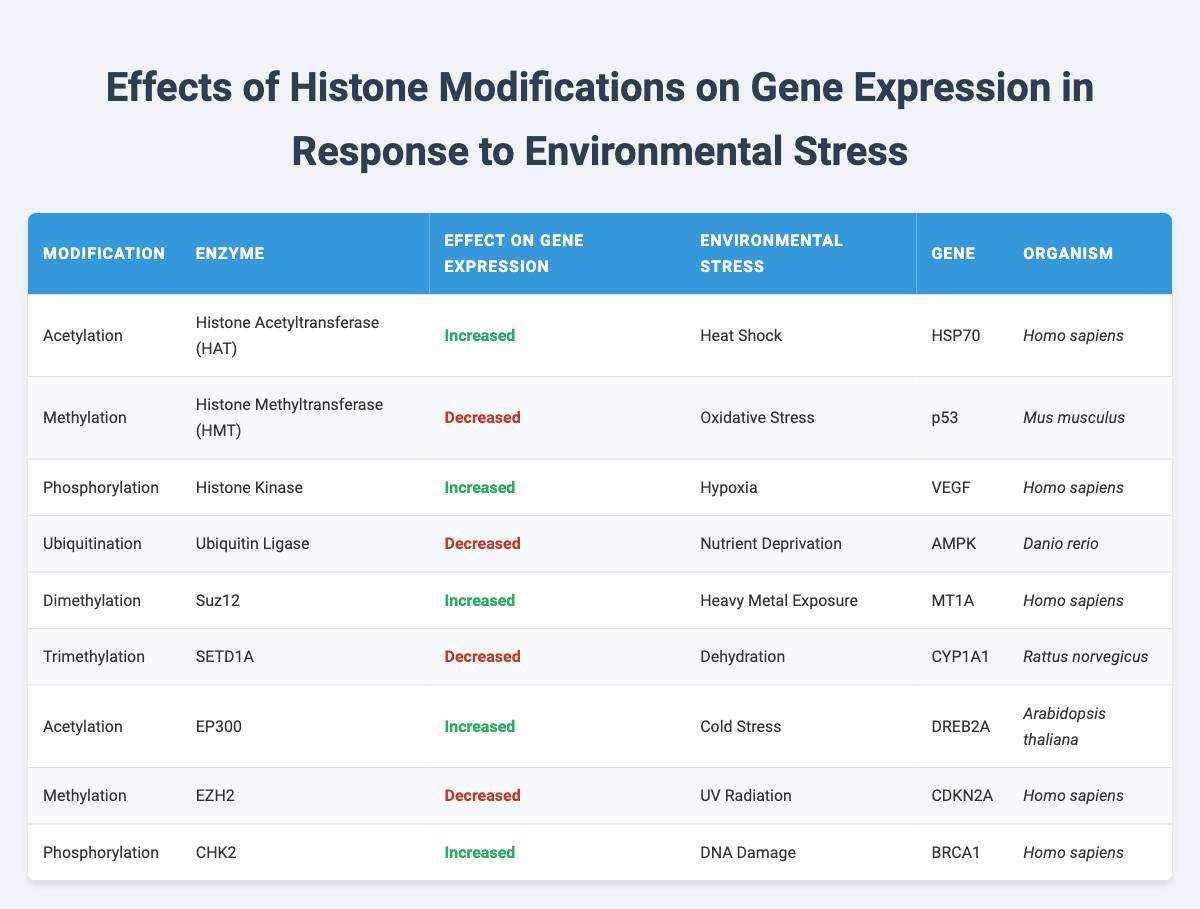What is the effect of Acetylation on gene expression in response to Heat Shock? The table indicates that Acetylation results in "Increased" gene expression when the organism is under Heat Shock conditions. Therefore, the effect can be directly observed from the relevant row.
Answer: Increased Which enzyme is associated with Methylation and what effect does it have during Oxidative Stress? Upon examining the table, Methylation is associated with the enzyme Histone Methyltransferase (HMT). Under Oxidative Stress, the effect of this modification is "Decreased" gene expression, as noted in the specific row.
Answer: Histone Methyltransferase (HMT), Decreased How many modifications result in increased gene expression? By reviewing the table, we identify three modifications that lead to increased gene expression: Acetylation in Heat Shock, Phosphorylation in Hypoxia, and Dimethylation in Heavy Metal Exposure. So, the total number of modifications is 3.
Answer: 3 Does the gene BRCA1 experience an increase in expression due to Phosphorylation in response to DNA Damage? The table specifies that for the gene BRCA1, the effect of Phosphorylation in response to DNA Damage is "Increased". Therefore, the answer to the question is affirmative based on the data provided.
Answer: Yes What is the common effect of Ubiquitination in response to Nutrient Deprivation? According to the table, Ubiquitination shows a "Decreased" effect on gene expression specifically under Nutrient Deprivation. Thus, the common effect is identified by looking at the corresponding row.
Answer: Decreased Which organism exhibits increased gene expression of DREB2A under Cold Stress? The table reveals that the organism Arabidopsis thaliana is the one where increased gene expression of DREB2A occurs in response to Cold Stress. This can be found by looking at the specific row related to DREB2A.
Answer: Arabidopsis thaliana What is the difference in the effect on gene expression between Trimethylation during Dehydration and Methylation during UV Radiation? Trimethylation has a "Decreased" effect on gene expression during Dehydration, while Methylation has a "Decreased" effect on gene expression during UV Radiation as well. Hence, the difference in terms of effect type is 0; both are decreased.
Answer: 0 Is there any histone modification that results in increased gene expression during Heavy Metal Exposure? The table indicates that Dimethylation increases gene expression during Heavy Metal Exposure, which confirms that there indeed is a modification that yields an increased effect.
Answer: Yes How does the effect of Acetylation differ between Heat Shock and Cold Stress? For Acetylation, under Heat Shock, the effect on gene expression is "Increased" as shown next to HSP70, while under Cold Stress, it also results in "Increased" for DREB2A. Therefore, the effect does not differ in this case; both conditions lead to an increase.
Answer: No difference 